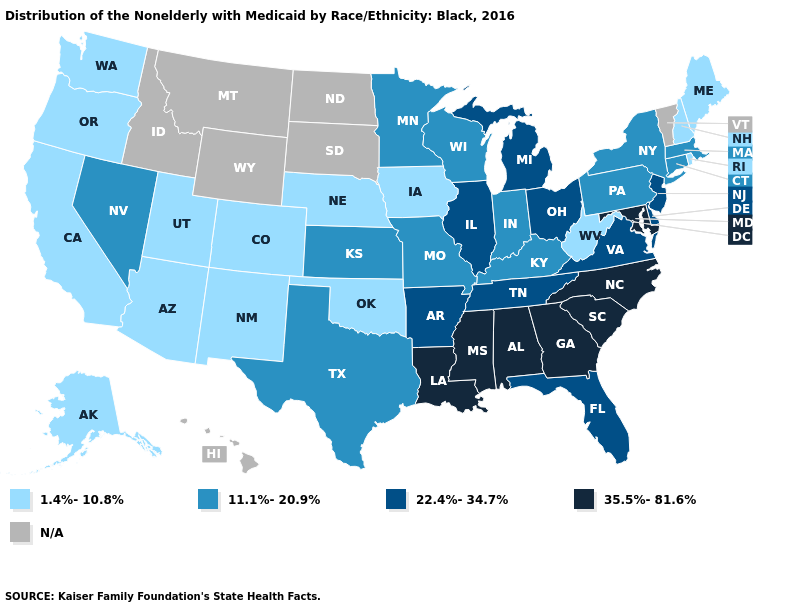Among the states that border New York , does New Jersey have the highest value?
Quick response, please. Yes. Among the states that border Pennsylvania , does New Jersey have the highest value?
Answer briefly. No. Does Wisconsin have the highest value in the USA?
Concise answer only. No. Does Maryland have the highest value in the South?
Answer briefly. Yes. What is the value of Florida?
Quick response, please. 22.4%-34.7%. Does Alabama have the highest value in the USA?
Write a very short answer. Yes. What is the value of Wisconsin?
Quick response, please. 11.1%-20.9%. Does Kentucky have the highest value in the USA?
Be succinct. No. What is the value of Missouri?
Write a very short answer. 11.1%-20.9%. Which states hav the highest value in the West?
Concise answer only. Nevada. What is the value of North Dakota?
Concise answer only. N/A. Name the states that have a value in the range N/A?
Write a very short answer. Hawaii, Idaho, Montana, North Dakota, South Dakota, Vermont, Wyoming. Among the states that border Connecticut , does New York have the lowest value?
Answer briefly. No. Among the states that border Indiana , which have the highest value?
Answer briefly. Illinois, Michigan, Ohio. 